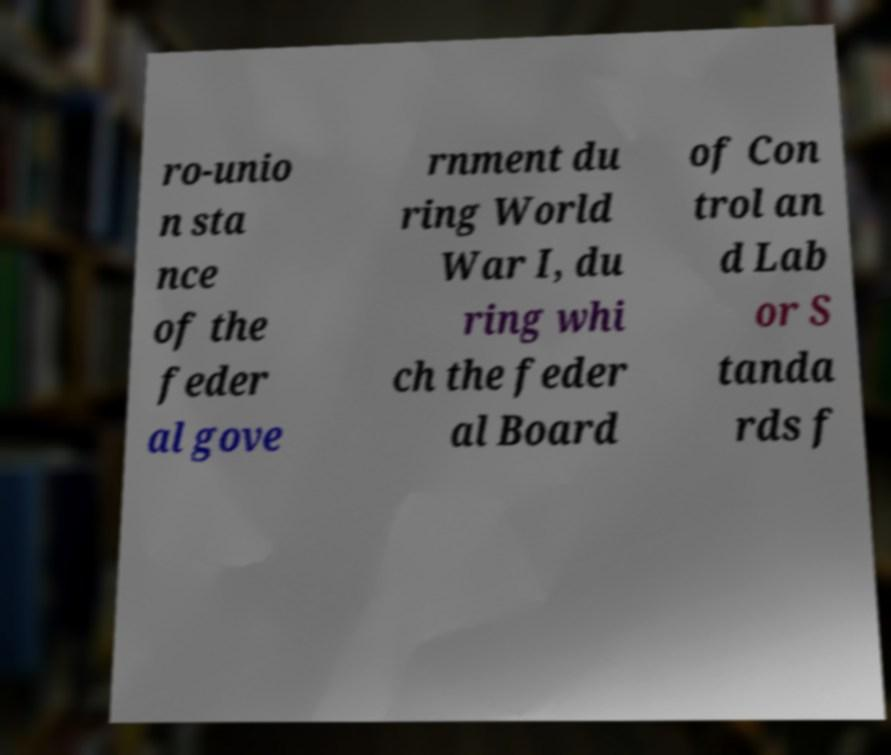Could you extract and type out the text from this image? ro-unio n sta nce of the feder al gove rnment du ring World War I, du ring whi ch the feder al Board of Con trol an d Lab or S tanda rds f 